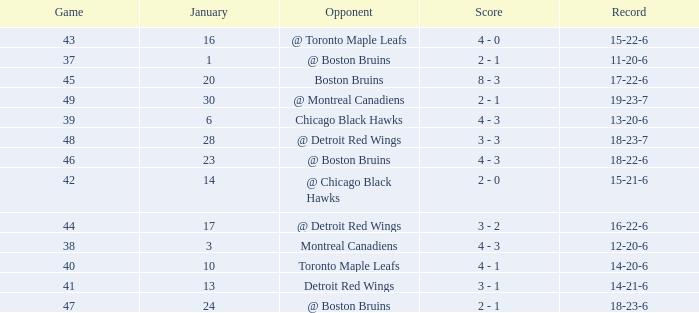Parse the table in full. {'header': ['Game', 'January', 'Opponent', 'Score', 'Record'], 'rows': [['43', '16', '@ Toronto Maple Leafs', '4 - 0', '15-22-6'], ['37', '1', '@ Boston Bruins', '2 - 1', '11-20-6'], ['45', '20', 'Boston Bruins', '8 - 3', '17-22-6'], ['49', '30', '@ Montreal Canadiens', '2 - 1', '19-23-7'], ['39', '6', 'Chicago Black Hawks', '4 - 3', '13-20-6'], ['48', '28', '@ Detroit Red Wings', '3 - 3', '18-23-7'], ['46', '23', '@ Boston Bruins', '4 - 3', '18-22-6'], ['42', '14', '@ Chicago Black Hawks', '2 - 0', '15-21-6'], ['44', '17', '@ Detroit Red Wings', '3 - 2', '16-22-6'], ['38', '3', 'Montreal Canadiens', '4 - 3', '12-20-6'], ['40', '10', 'Toronto Maple Leafs', '4 - 1', '14-20-6'], ['41', '13', 'Detroit Red Wings', '3 - 1', '14-21-6'], ['47', '24', '@ Boston Bruins', '2 - 1', '18-23-6']]} What was the total number of games on January 20? 1.0. 